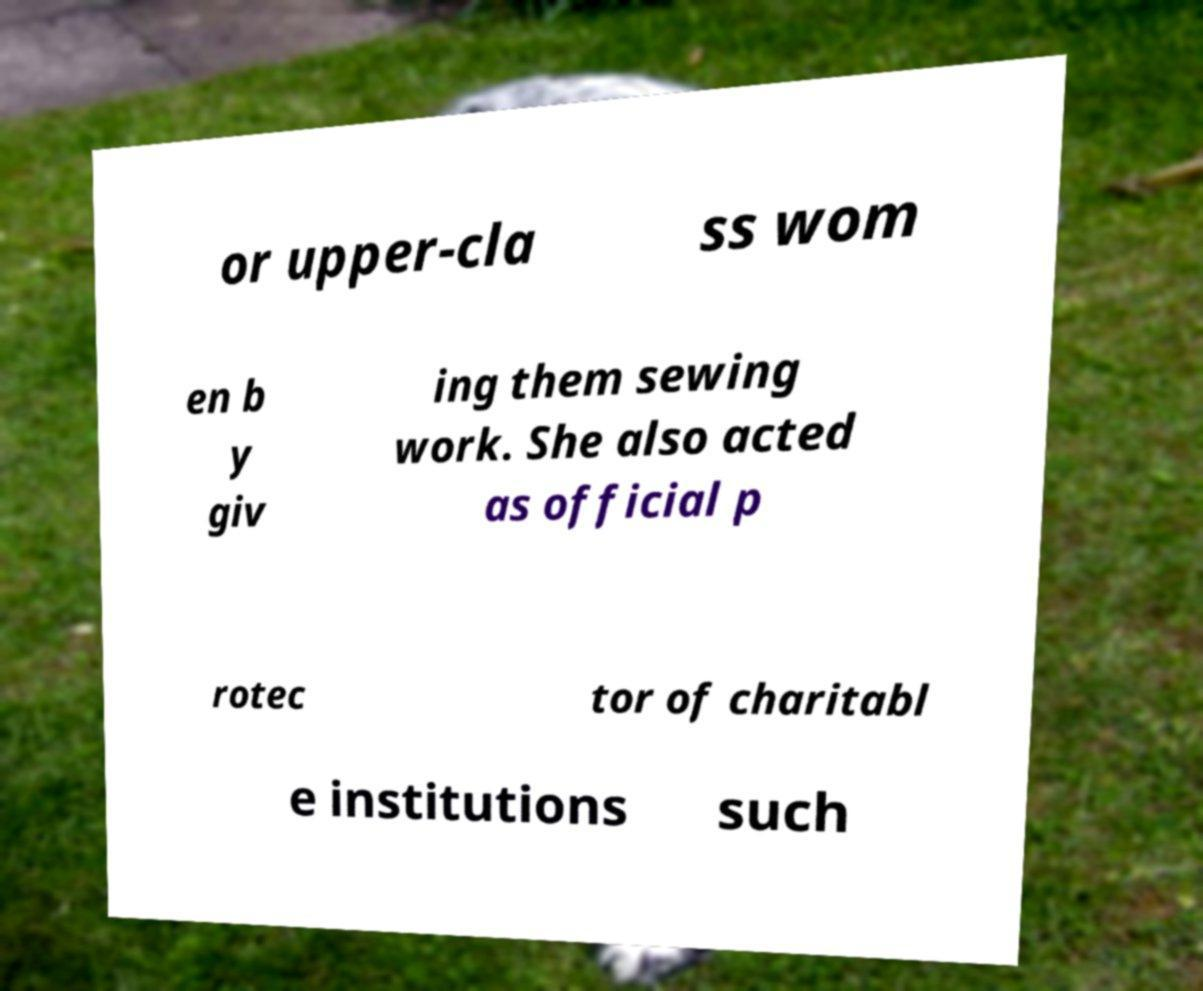What messages or text are displayed in this image? I need them in a readable, typed format. or upper-cla ss wom en b y giv ing them sewing work. She also acted as official p rotec tor of charitabl e institutions such 